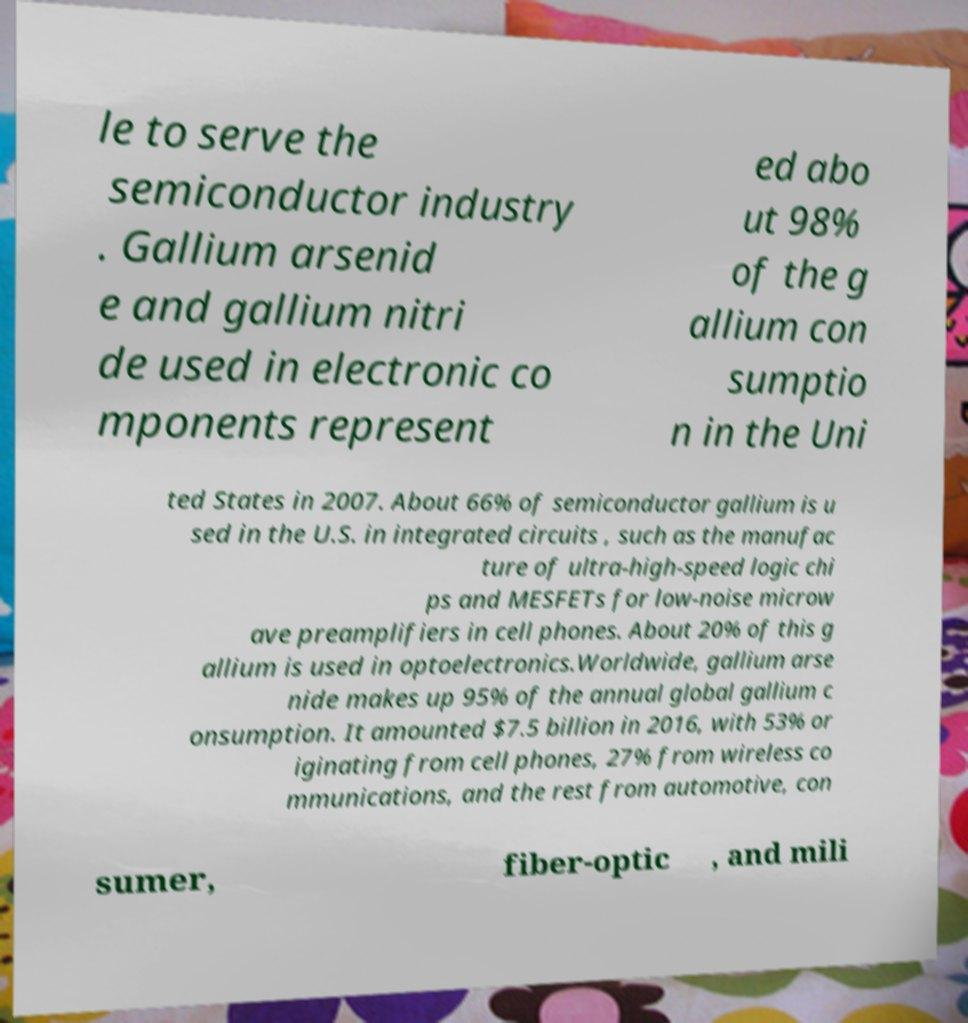Can you read and provide the text displayed in the image?This photo seems to have some interesting text. Can you extract and type it out for me? le to serve the semiconductor industry . Gallium arsenid e and gallium nitri de used in electronic co mponents represent ed abo ut 98% of the g allium con sumptio n in the Uni ted States in 2007. About 66% of semiconductor gallium is u sed in the U.S. in integrated circuits , such as the manufac ture of ultra-high-speed logic chi ps and MESFETs for low-noise microw ave preamplifiers in cell phones. About 20% of this g allium is used in optoelectronics.Worldwide, gallium arse nide makes up 95% of the annual global gallium c onsumption. It amounted $7.5 billion in 2016, with 53% or iginating from cell phones, 27% from wireless co mmunications, and the rest from automotive, con sumer, fiber-optic , and mili 